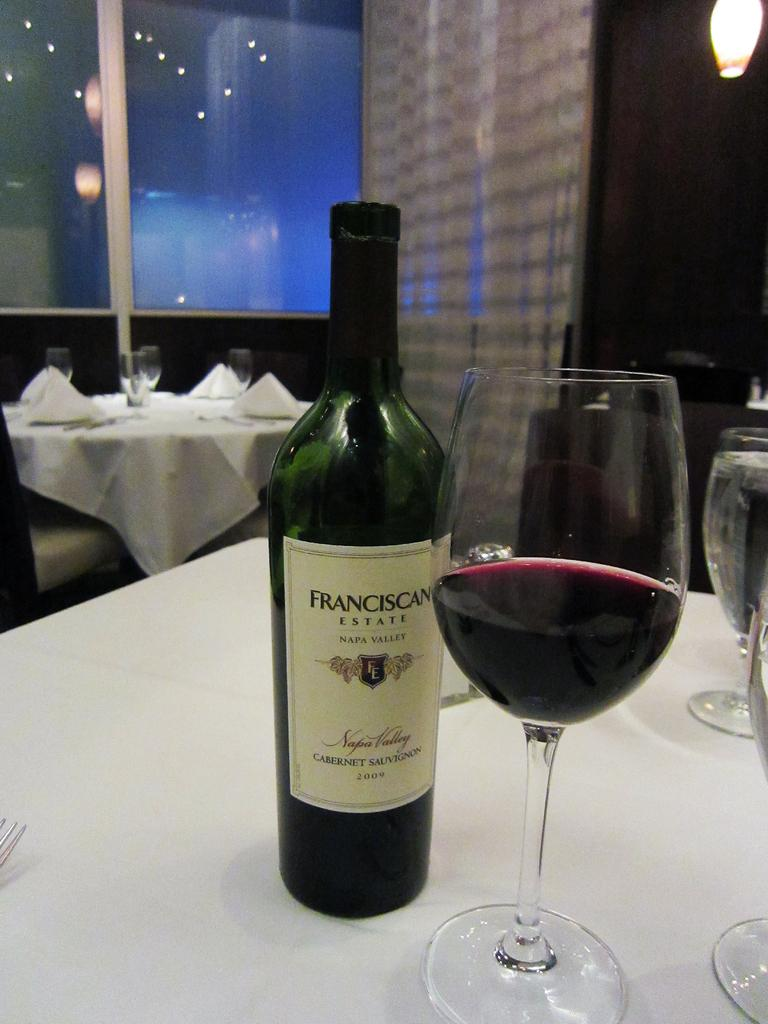<image>
Give a short and clear explanation of the subsequent image. A half full wine glass is sitting on a table, next to an open bottle of Franciscan EstateCabernet Sauvignon. 